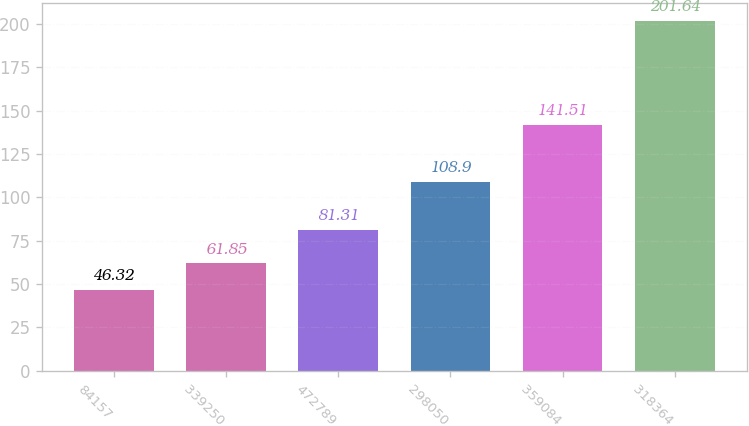Convert chart. <chart><loc_0><loc_0><loc_500><loc_500><bar_chart><fcel>84157<fcel>339250<fcel>472789<fcel>298050<fcel>359084<fcel>318364<nl><fcel>46.32<fcel>61.85<fcel>81.31<fcel>108.9<fcel>141.51<fcel>201.64<nl></chart> 